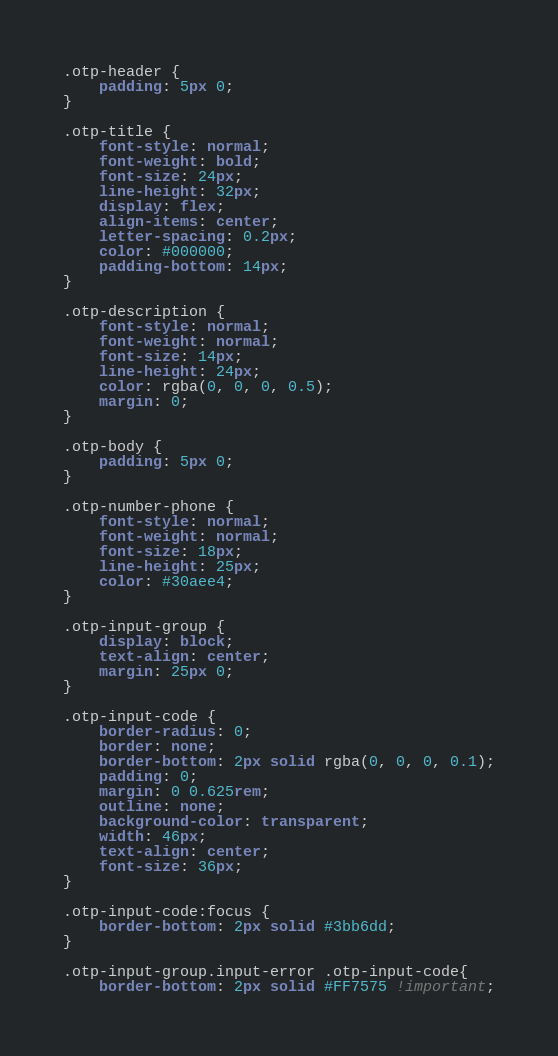<code> <loc_0><loc_0><loc_500><loc_500><_CSS_>.otp-header {
    padding: 5px 0;
}

.otp-title {
    font-style: normal;
    font-weight: bold;
    font-size: 24px;
    line-height: 32px;
    display: flex;
    align-items: center;
    letter-spacing: 0.2px;
    color: #000000;
    padding-bottom: 14px;
}

.otp-description {
    font-style: normal;
    font-weight: normal;
    font-size: 14px;
    line-height: 24px;
    color: rgba(0, 0, 0, 0.5);
    margin: 0;
}

.otp-body {
    padding: 5px 0;
}

.otp-number-phone {
    font-style: normal;
    font-weight: normal;
    font-size: 18px;
    line-height: 25px;
    color: #30aee4;
}

.otp-input-group {
    display: block;
    text-align: center;
    margin: 25px 0;
}

.otp-input-code {
    border-radius: 0;
    border: none;
    border-bottom: 2px solid rgba(0, 0, 0, 0.1);
    padding: 0;
    margin: 0 0.625rem;
    outline: none;
    background-color: transparent;
    width: 46px;
    text-align: center;
    font-size: 36px;
}

.otp-input-code:focus {
    border-bottom: 2px solid #3bb6dd;
}

.otp-input-group.input-error .otp-input-code{
    border-bottom: 2px solid #FF7575 !important;</code> 